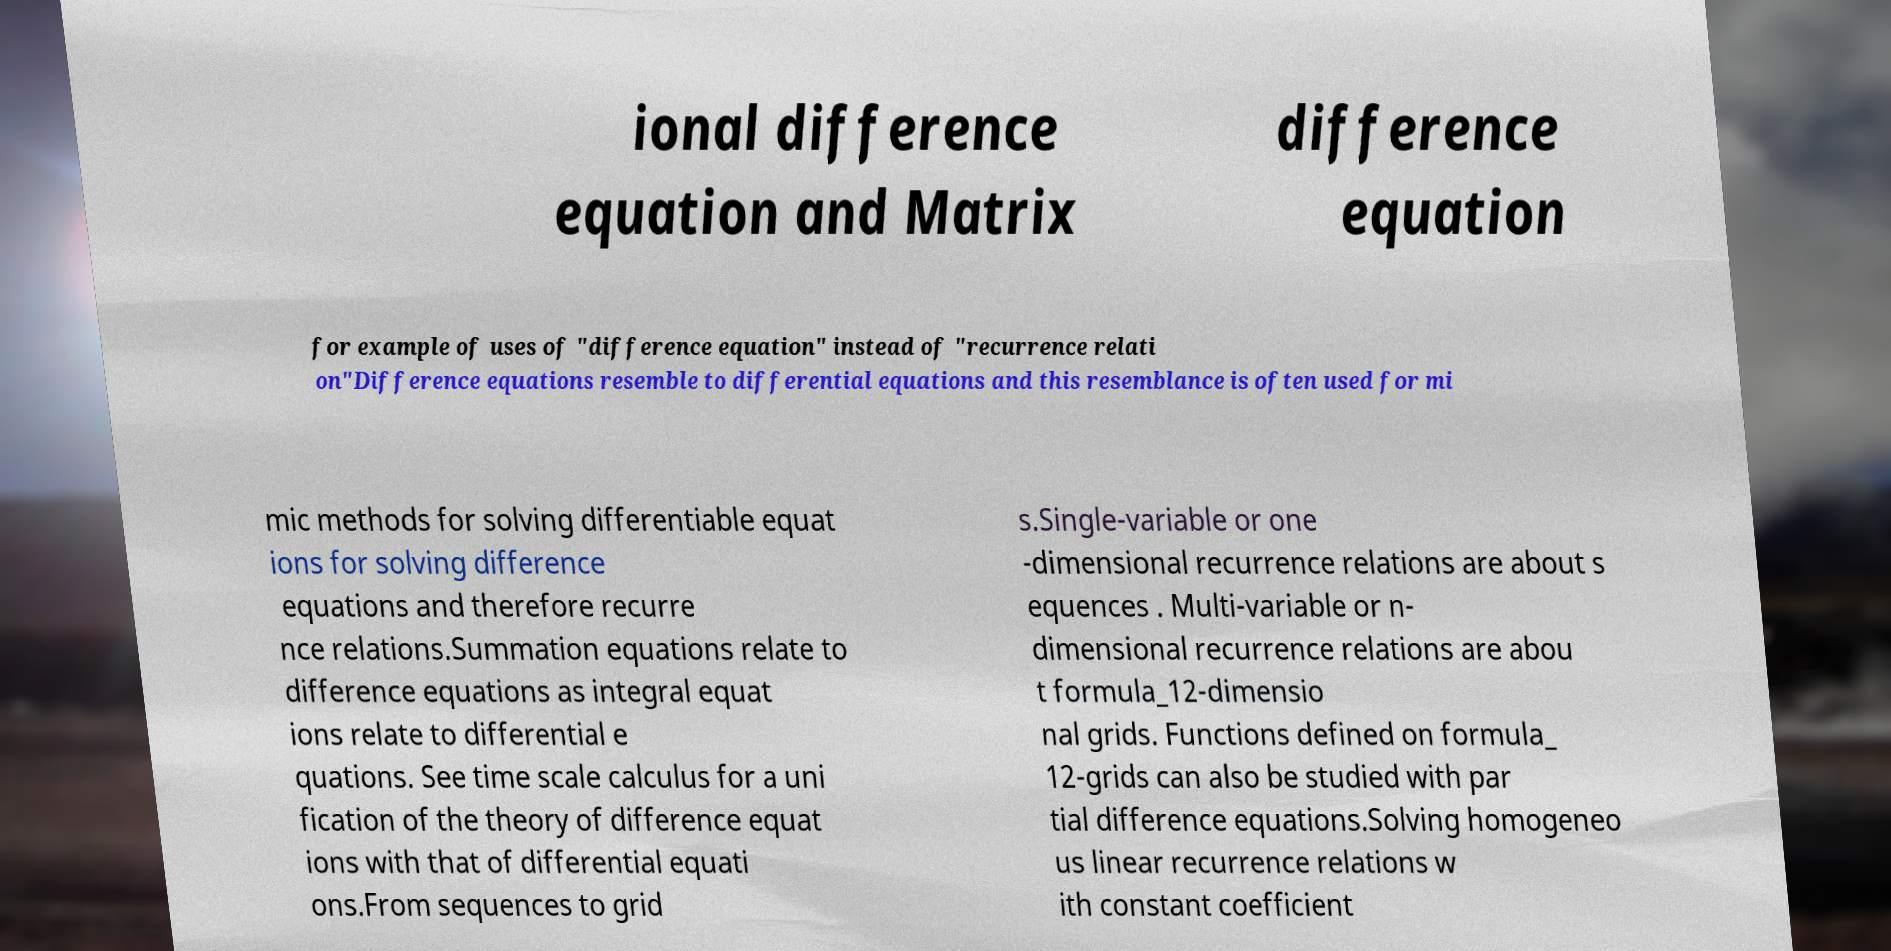Could you extract and type out the text from this image? ional difference equation and Matrix difference equation for example of uses of "difference equation" instead of "recurrence relati on"Difference equations resemble to differential equations and this resemblance is often used for mi mic methods for solving differentiable equat ions for solving difference equations and therefore recurre nce relations.Summation equations relate to difference equations as integral equat ions relate to differential e quations. See time scale calculus for a uni fication of the theory of difference equat ions with that of differential equati ons.From sequences to grid s.Single-variable or one -dimensional recurrence relations are about s equences . Multi-variable or n- dimensional recurrence relations are abou t formula_12-dimensio nal grids. Functions defined on formula_ 12-grids can also be studied with par tial difference equations.Solving homogeneo us linear recurrence relations w ith constant coefficient 